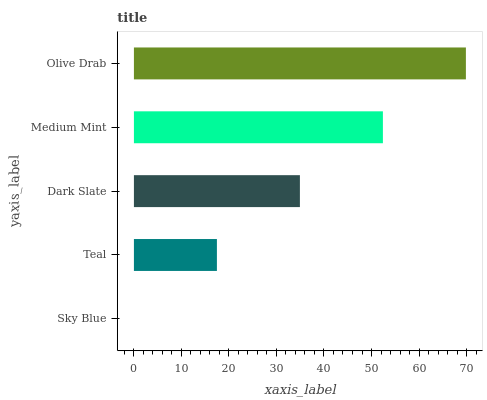Is Sky Blue the minimum?
Answer yes or no. Yes. Is Olive Drab the maximum?
Answer yes or no. Yes. Is Teal the minimum?
Answer yes or no. No. Is Teal the maximum?
Answer yes or no. No. Is Teal greater than Sky Blue?
Answer yes or no. Yes. Is Sky Blue less than Teal?
Answer yes or no. Yes. Is Sky Blue greater than Teal?
Answer yes or no. No. Is Teal less than Sky Blue?
Answer yes or no. No. Is Dark Slate the high median?
Answer yes or no. Yes. Is Dark Slate the low median?
Answer yes or no. Yes. Is Olive Drab the high median?
Answer yes or no. No. Is Medium Mint the low median?
Answer yes or no. No. 